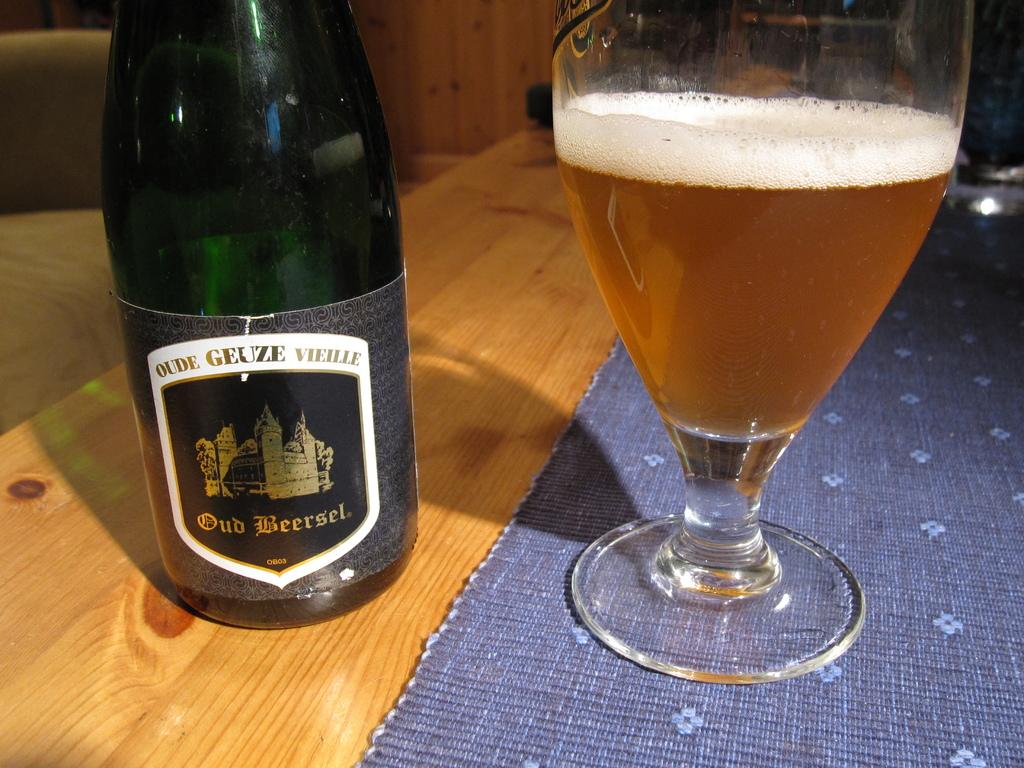<image>
Share a concise interpretation of the image provided. a bottle of oude geuze vieille beer next to a glass of the same 